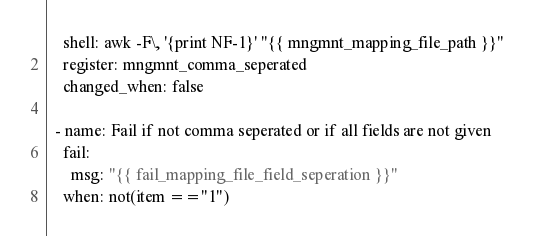Convert code to text. <code><loc_0><loc_0><loc_500><loc_500><_YAML_>    shell: awk -F\, '{print NF-1}' "{{ mngmnt_mapping_file_path }}"
    register: mngmnt_comma_seperated
    changed_when: false

  - name: Fail if not comma seperated or if all fields are not given
    fail:
      msg: "{{ fail_mapping_file_field_seperation }}"
    when: not(item =="1")</code> 